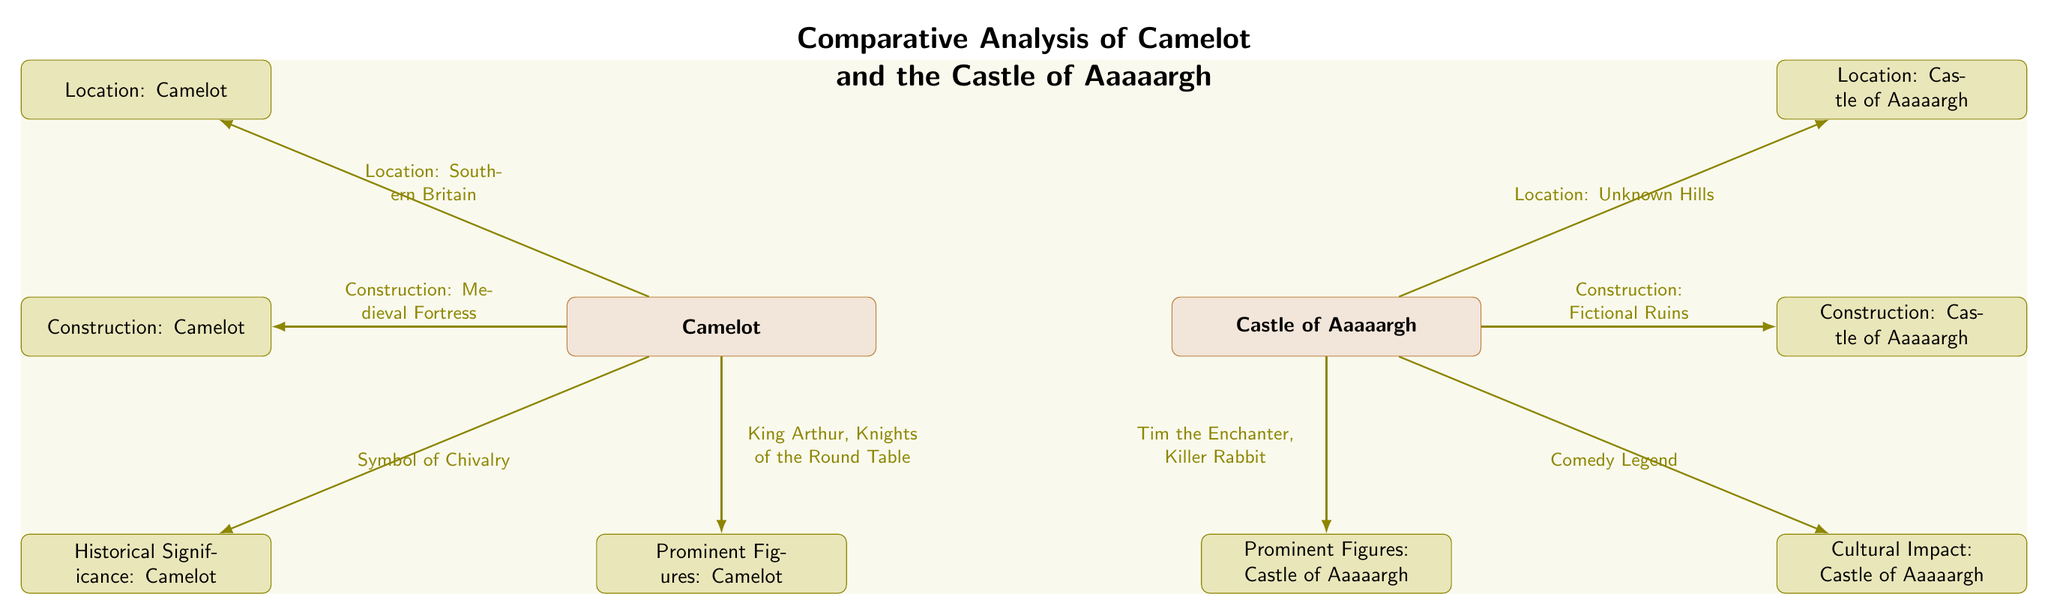What is the location of Camelot? The diagram shows that the location of Camelot is denoted as "Southern Britain," connected with an arrow from the Camelot rectangle to the corresponding feature node.
Answer: Southern Britain What kind of construction does the Castle of Aaaaargh have? The diagram indicates the construction of the Castle of Aaaaargh as "Fictional Ruins," shown with an arrow that leads from the Castle of Aaaaargh rectangle to the associated feature node.
Answer: Fictional Ruins Who are prominent figures associated with Camelot? According to the diagram, the prominent figures of Camelot are listed as "King Arthur, Knights of the Round Table," found near the bottom of the Camelot rectangle connected with an arrow to the relevant feature node.
Answer: King Arthur, Knights of the Round Table What cultural impact is associated with the Castle of Aaaaargh? The diagram specifies that the cultural impact of the Castle of Aaaaargh is referred to as "Comedy Legend," shown with an arrow pointing from the Castle of Aaaaargh rectangle to the corresponding feature node.
Answer: Comedy Legend How many prominent figures are associated with the Castle of Aaaaargh? The diagram indicates that there is one set of prominent figures associated with the Castle of Aaaaargh, which is represented visually by a single arrow and a corresponding label stating "Tim the Enchanter, Killer Rabbit."
Answer: 1 set What is the historical significance of Camelot? The diagram reveals that the historical significance of Camelot is identified as "Symbol of Chivalry," connected via an arrow to the relevant feature node, indicating what Camelot represents in the legends.
Answer: Symbol of Chivalry Which castle is associated with a certain location in "Unknown Hills"? The diagram shows that the Castle of Aaaaargh is linked to the label "Location: Unknown Hills," indicating its setting. This is evident by the arrow leading from the Castle of Aaaaargh rectangle to the corresponding feature node.
Answer: Castle of Aaaaargh What is the arrow indicating from Camelot to its historical significance? The arrow from Camelot pointing to "Symbol of Chivalry" signifies the connection between Camelot and its reputation in history, portraying its importance in the chivalric tradition.
Answer: Symbol of Chivalry What is the contrast between the construction types of Camelot and the Castle of Aaaaargh? The diagram illustrates that Camelot is built as a "Medieval Fortress," in contrast to the "Fictional Ruins" of the Castle of Aaaaargh, highlighting the difference in their respective structures. This is seen through the arrows leading to each structure's description.
Answer: Medieval Fortress vs. Fictional Ruins 